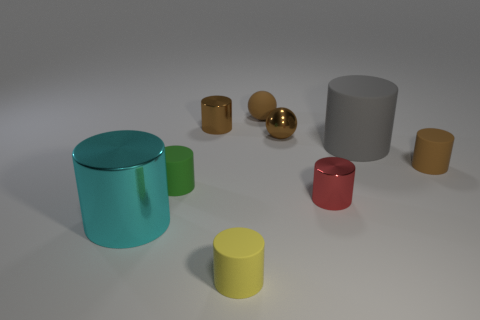How many other things are the same shape as the small green matte thing?
Keep it short and to the point. 6. There is a tiny brown thing to the left of the object in front of the large cylinder that is on the left side of the yellow cylinder; what is it made of?
Offer a very short reply. Metal. Do the green matte object and the gray thing have the same size?
Keep it short and to the point. No. There is a thing that is in front of the big rubber thing and to the right of the red shiny object; what is its shape?
Your answer should be very brief. Cylinder. How many brown objects have the same material as the big cyan thing?
Provide a short and direct response. 2. There is a tiny matte cylinder that is on the right side of the yellow rubber object; what number of tiny green objects are on the right side of it?
Your answer should be very brief. 0. There is a big thing that is right of the tiny metallic thing left of the rubber object behind the tiny brown metallic sphere; what is its shape?
Offer a terse response. Cylinder. There is a shiny object that is the same color as the small metallic sphere; what is its size?
Provide a succinct answer. Small. How many objects are either big yellow rubber cylinders or spheres?
Offer a very short reply. 2. What is the color of the rubber sphere that is the same size as the green rubber object?
Give a very brief answer. Brown. 